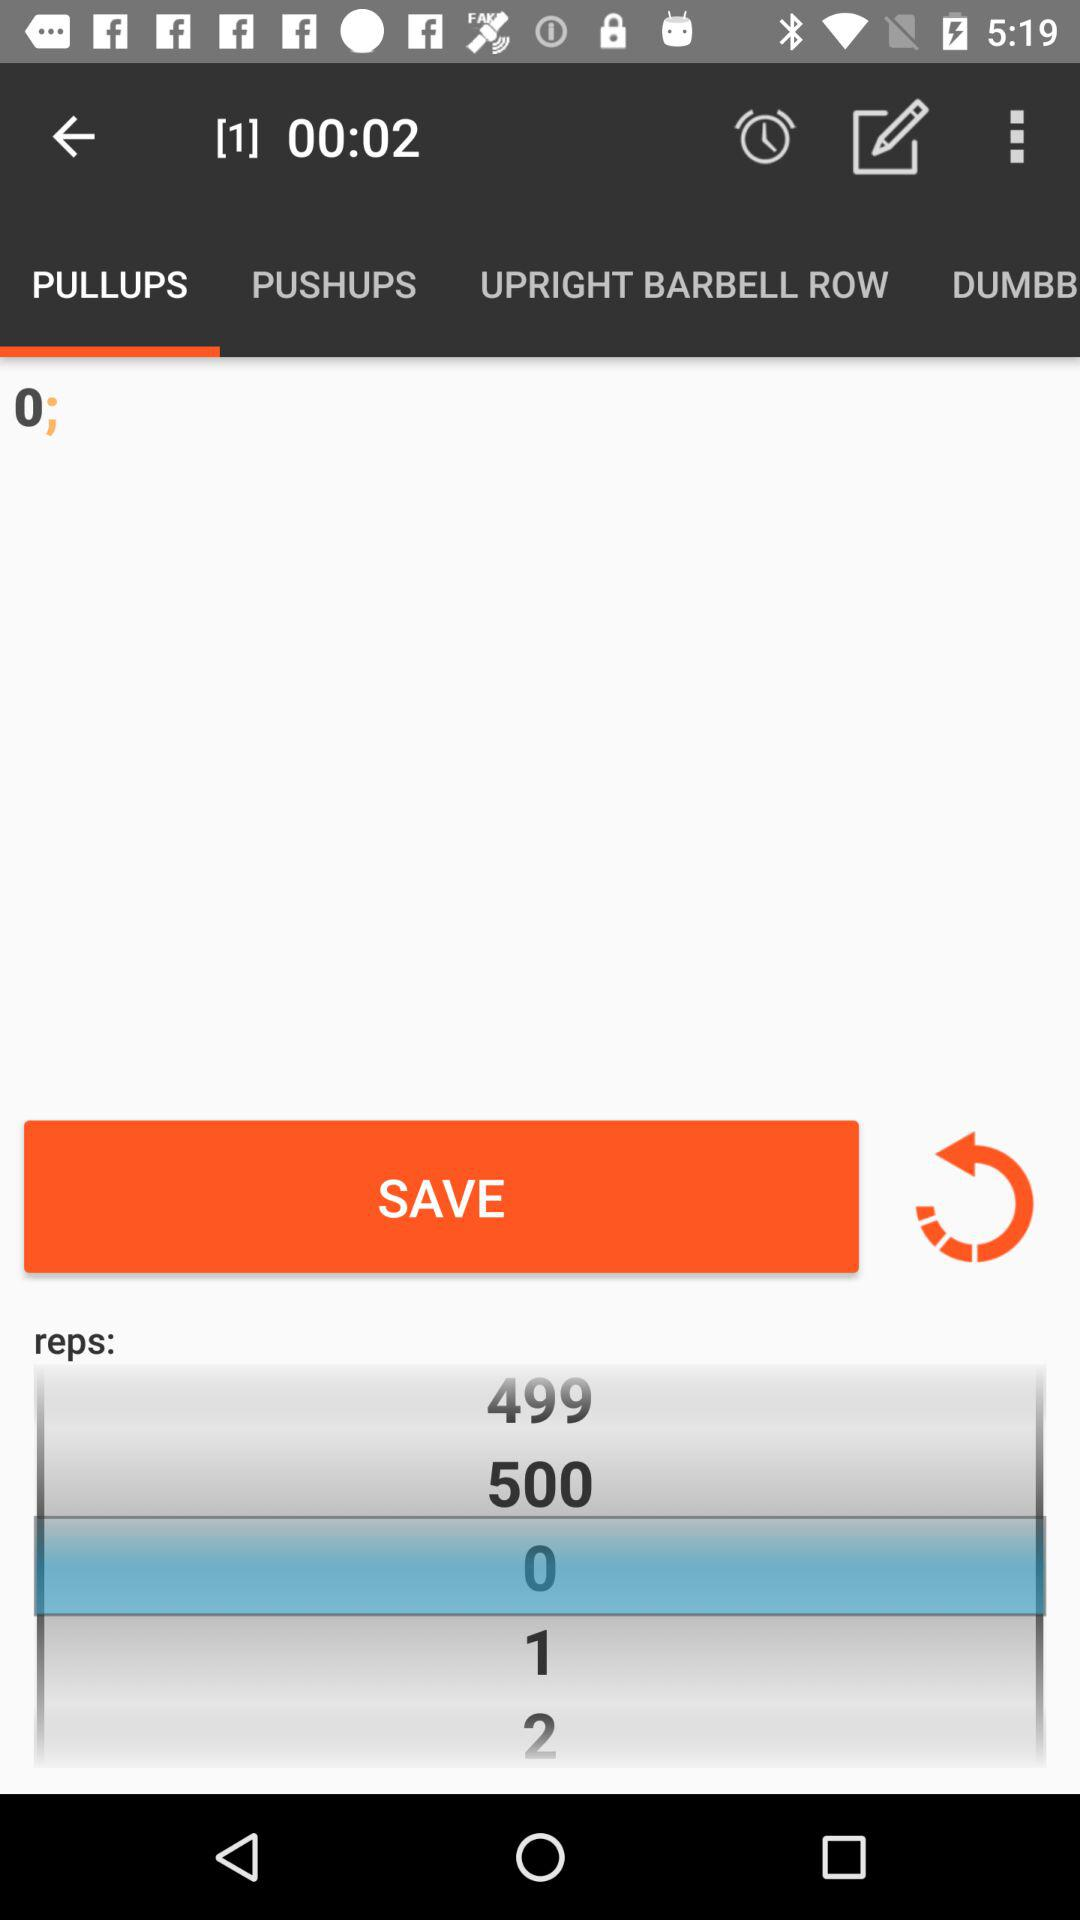What is the selected number of repetitions in "PULLUPS"? The selected number of repetitions in "PULLUPS" is 0. 